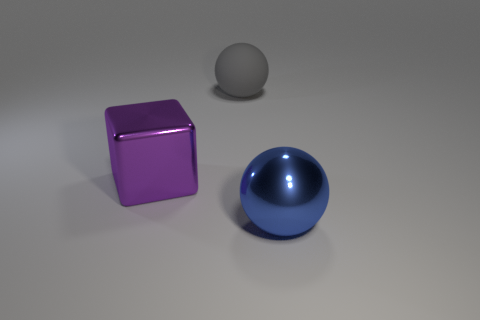Can you describe the lighting in the scene? The scene is lit from above, casting soft shadows directly underneath the objects. This lighting creates gentle gradients on the spheres and subtle reflections on the purple cube, giving an overall soft yet clear illumination indicative of a diffuse light source. 